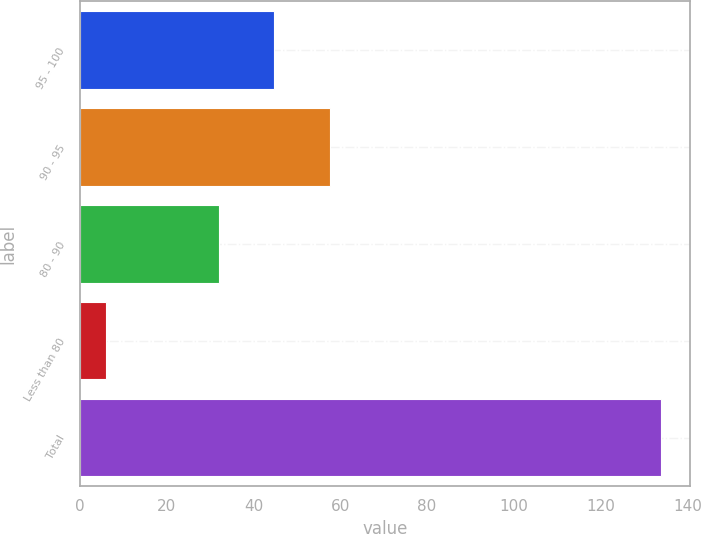<chart> <loc_0><loc_0><loc_500><loc_500><bar_chart><fcel>95 - 100<fcel>90 - 95<fcel>80 - 90<fcel>Less than 80<fcel>Total<nl><fcel>44.8<fcel>57.6<fcel>32<fcel>6<fcel>134<nl></chart> 